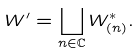<formula> <loc_0><loc_0><loc_500><loc_500>W ^ { \prime } = \coprod _ { n \in { \mathbb { C } } } W _ { ( n ) } ^ { * } .</formula> 